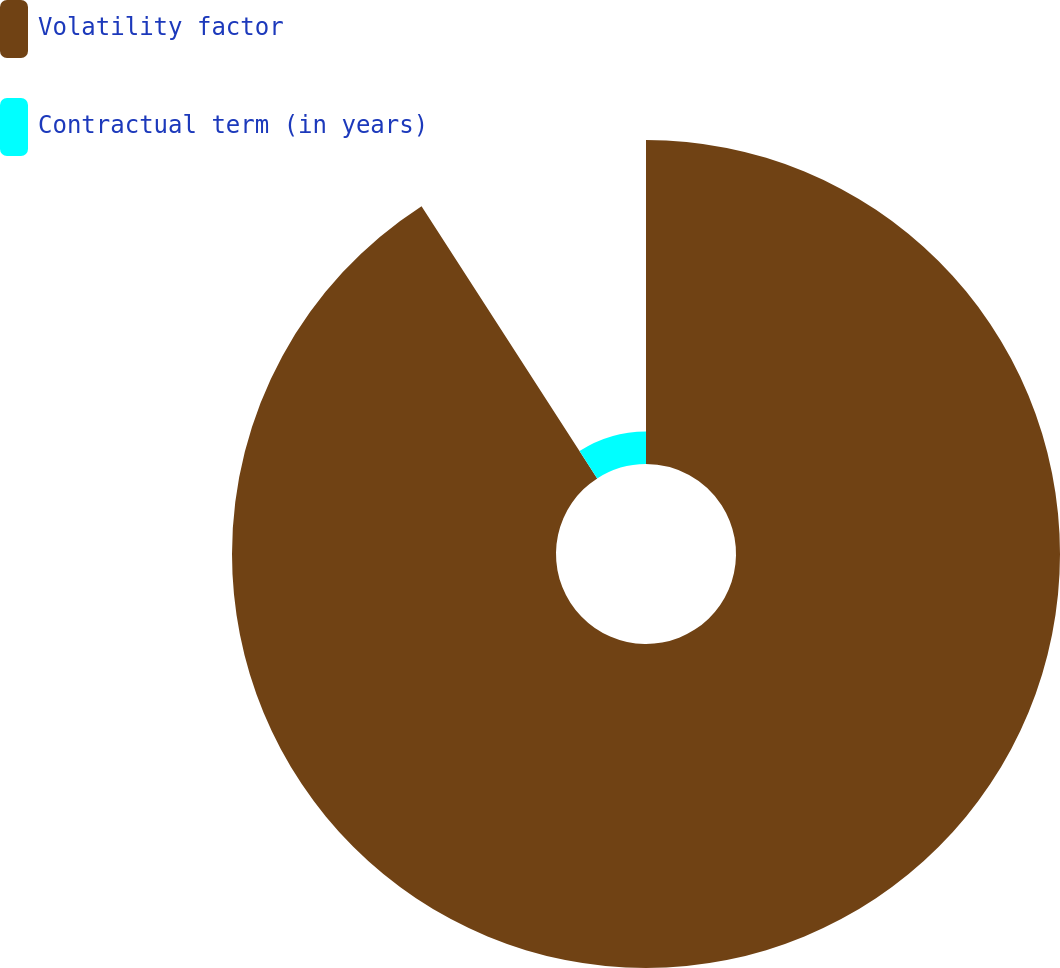<chart> <loc_0><loc_0><loc_500><loc_500><pie_chart><fcel>Volatility factor<fcel>Contractual term (in years)<nl><fcel>90.88%<fcel>9.12%<nl></chart> 